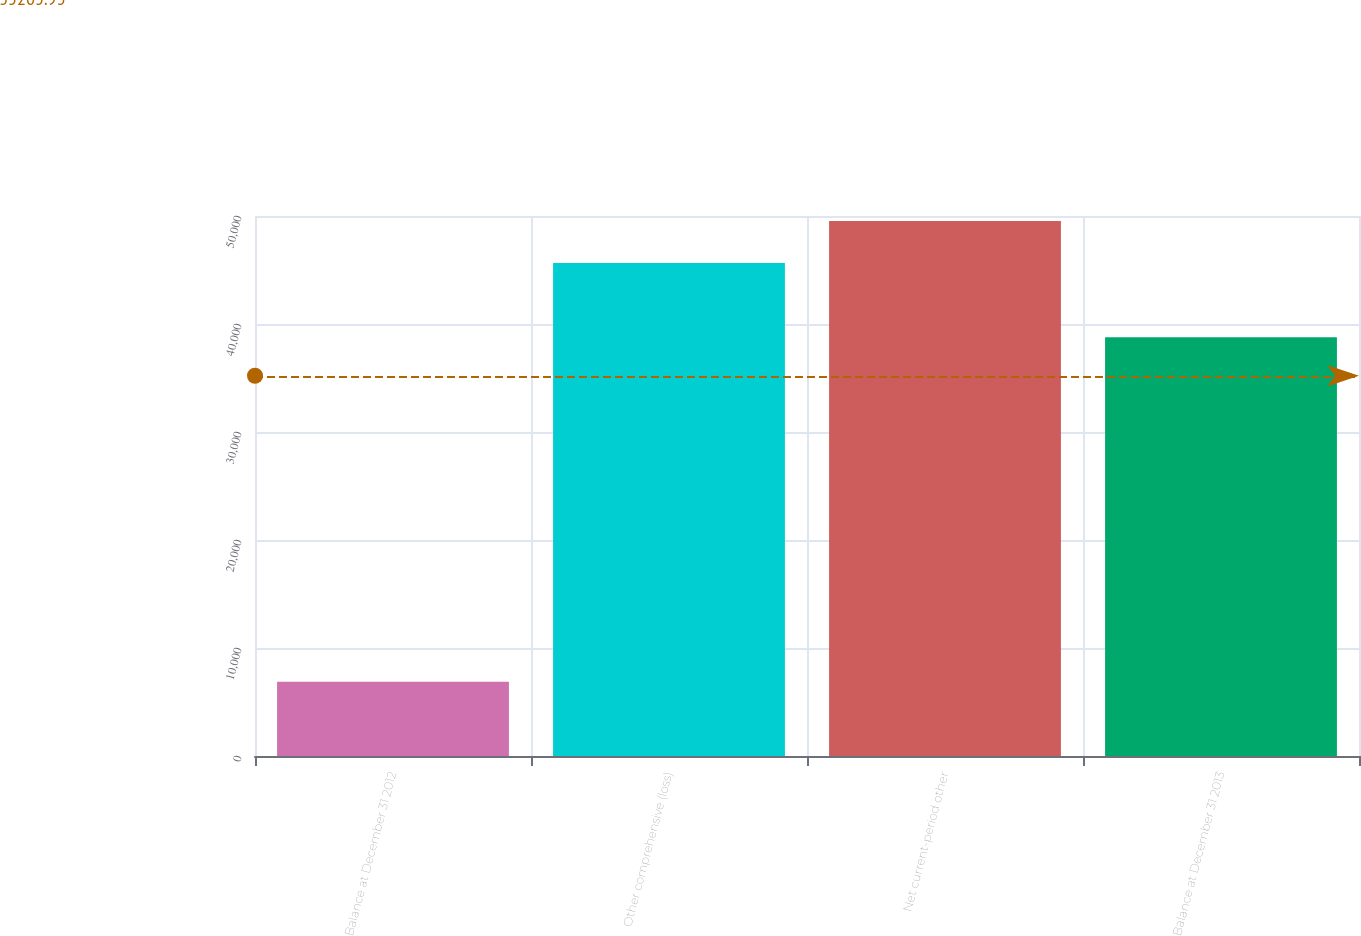Convert chart to OTSL. <chart><loc_0><loc_0><loc_500><loc_500><bar_chart><fcel>Balance at December 31 2012<fcel>Other comprehensive (loss)<fcel>Net current-period other<fcel>Balance at December 31 2013<nl><fcel>6882<fcel>45649<fcel>49525.7<fcel>38767<nl></chart> 